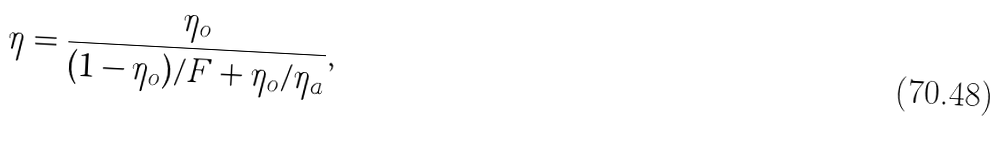<formula> <loc_0><loc_0><loc_500><loc_500>\eta = \frac { \eta _ { o } } { ( 1 - \eta _ { o } ) / F + \eta _ { o } / \eta _ { a } } ,</formula> 